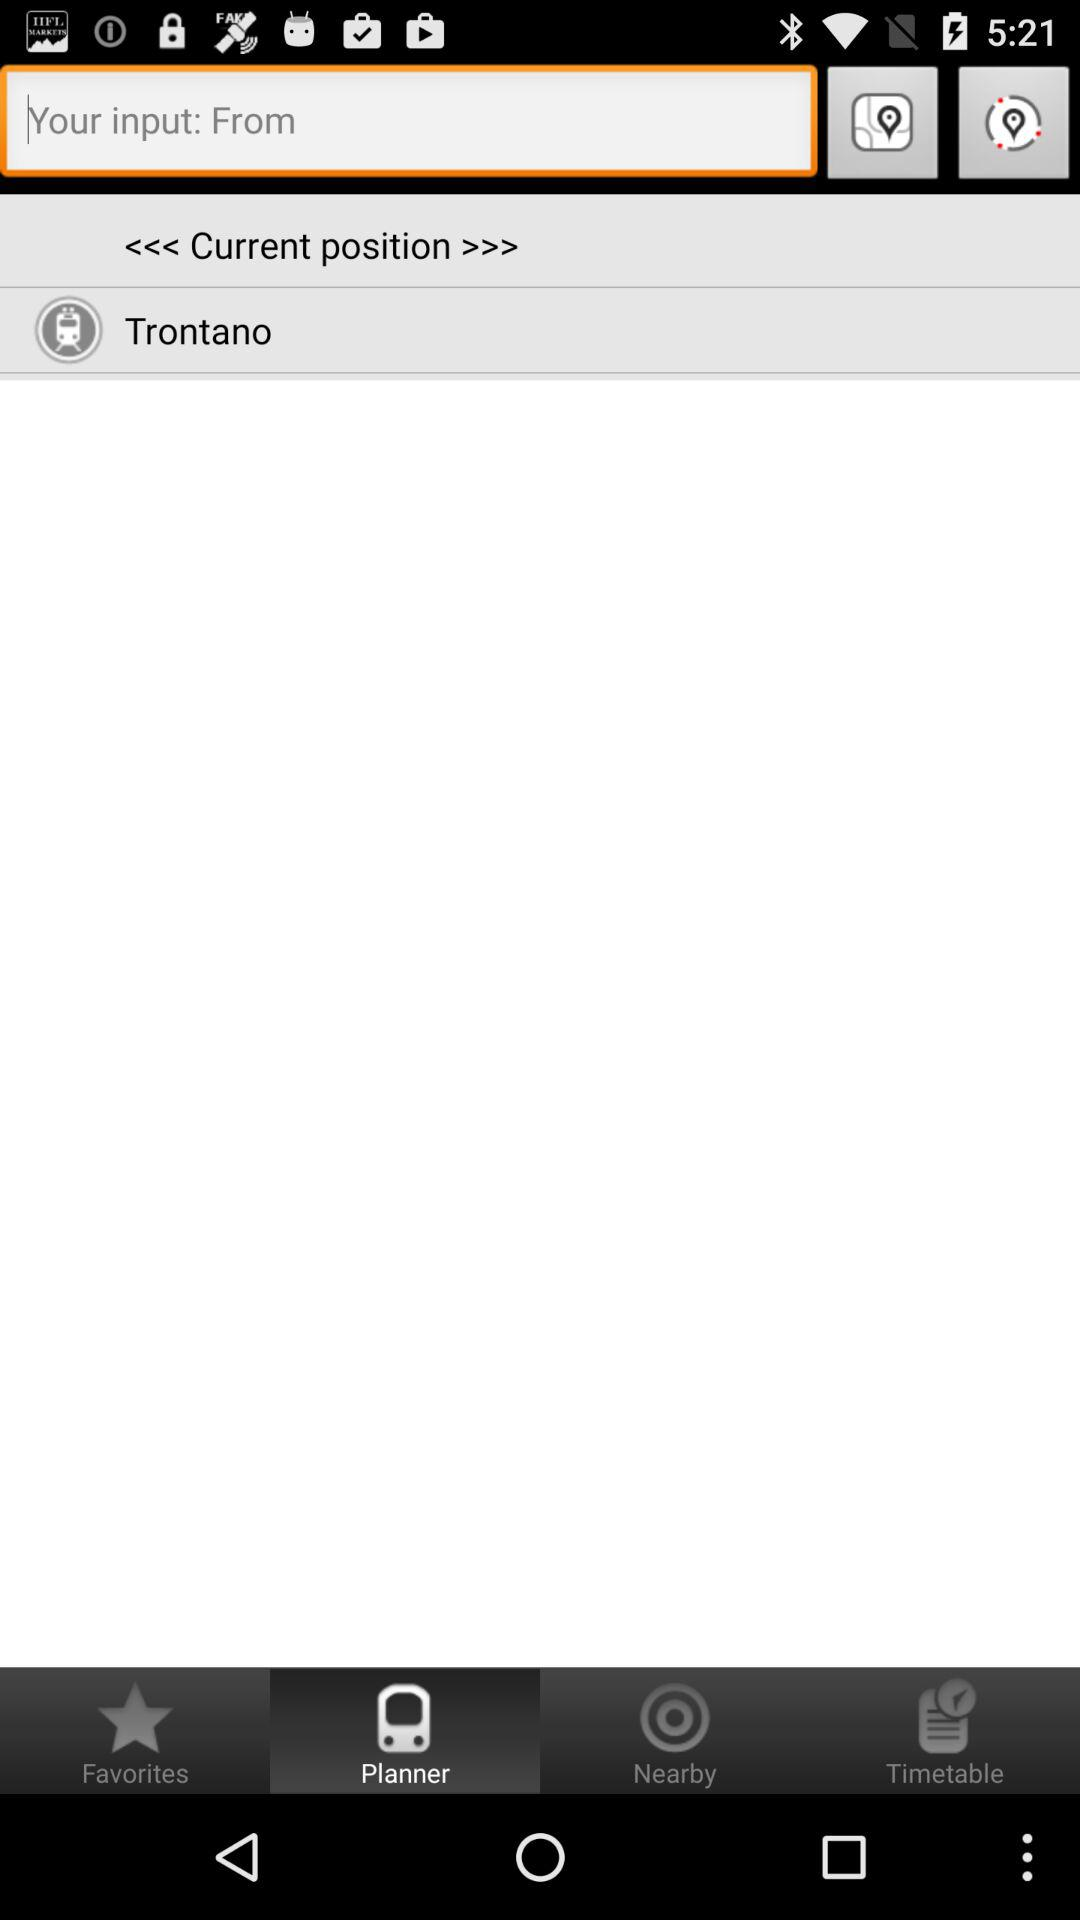What is the current position? The current position is Trontano. 